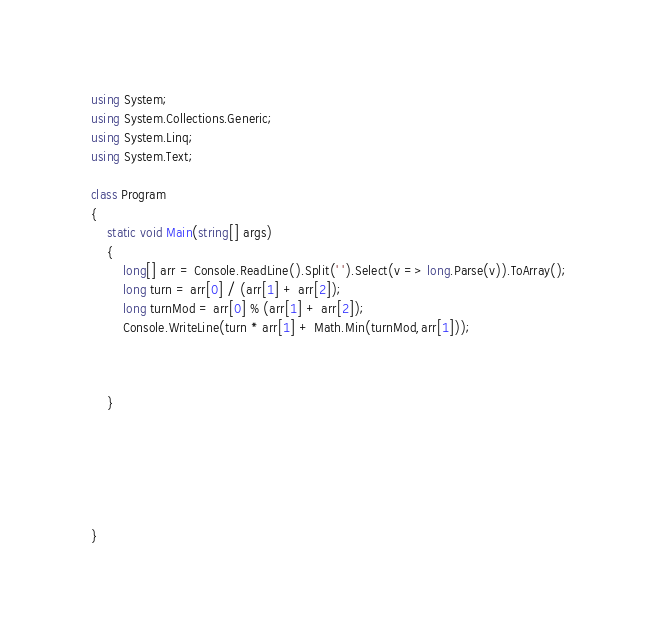Convert code to text. <code><loc_0><loc_0><loc_500><loc_500><_C#_>using System;
using System.Collections.Generic;
using System.Linq;
using System.Text;

class Program
{
    static void Main(string[] args)
    {
        long[] arr = Console.ReadLine().Split(' ').Select(v => long.Parse(v)).ToArray();
        long turn = arr[0] / (arr[1] + arr[2]);
        long turnMod = arr[0] % (arr[1] + arr[2]);
        Console.WriteLine(turn * arr[1] + Math.Min(turnMod,arr[1]));



    }

  




}



</code> 